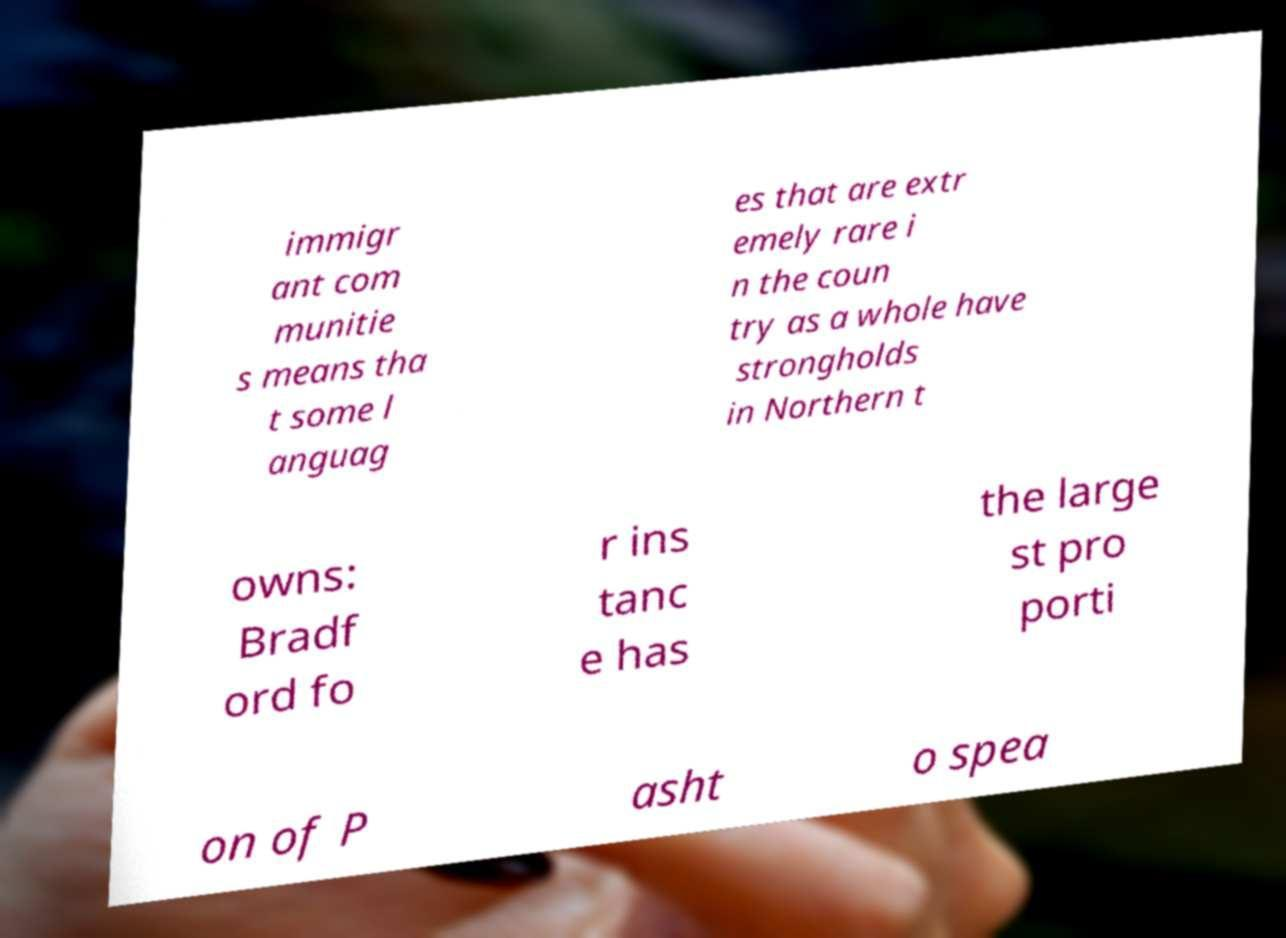Can you read and provide the text displayed in the image?This photo seems to have some interesting text. Can you extract and type it out for me? immigr ant com munitie s means tha t some l anguag es that are extr emely rare i n the coun try as a whole have strongholds in Northern t owns: Bradf ord fo r ins tanc e has the large st pro porti on of P asht o spea 